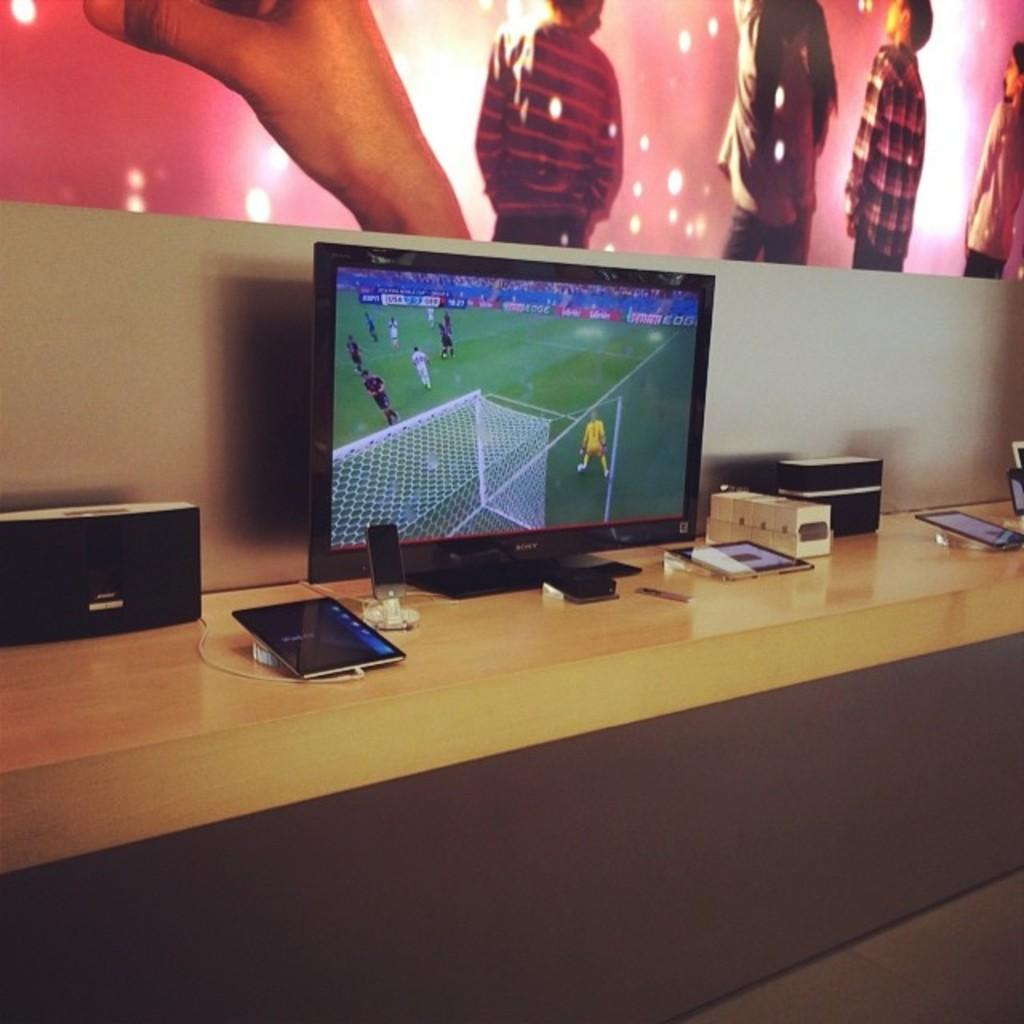What type of objects can be seen in the image? There are electronic devices in the image. What is the surface made of that the electronic devices are placed on? The electronic devices are on a wooden surface. Is the maid in the image performing any tasks related to driving or measuring? There is no maid present in the image, and the electronic devices and wooden surface do not suggest any tasks related to driving or measuring. 